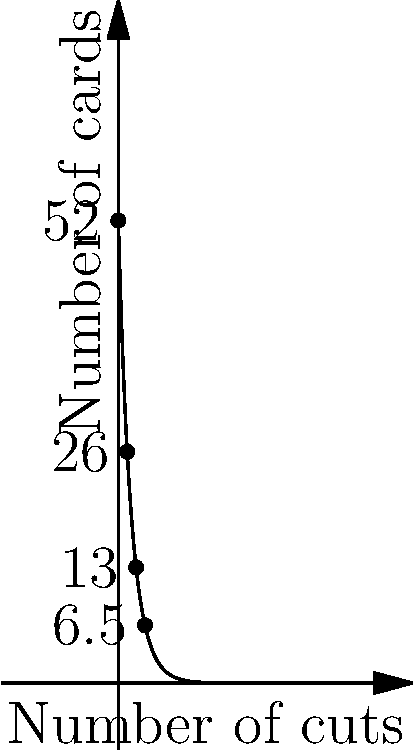Imagine you're performing your favorite card trick with a standard deck of 52 cards. After each trick, you cut the deck in half, removing the bottom half. If you continue this process indefinitely, what is the limit of the number of cards remaining in the deck? Express your answer mathematically using limit notation. Let's approach this step-by-step:

1) Initially, we start with 52 cards.

2) After the first cut, we have 52/2 = 26 cards.

3) After the second cut, we have 26/2 = 13 cards.

4) After the third cut, we have 13/2 = 6.5 cards (theoretically).

5) We can see a pattern forming. After $n$ cuts, the number of cards is:

   $52 / 2^n$

6) As we continue this process indefinitely, $n$ approaches infinity.

7) We can express this mathematically as a limit:

   $\lim_{n \to \infty} \frac{52}{2^n}$

8) As $n$ gets larger and larger, $2^n$ becomes an extremely large number.

9) When we divide 52 by an extremely large number, the result gets closer and closer to 0.

Therefore, the limit of this process as $n$ approaches infinity is 0.
Answer: $\lim_{n \to \infty} \frac{52}{2^n} = 0$ 